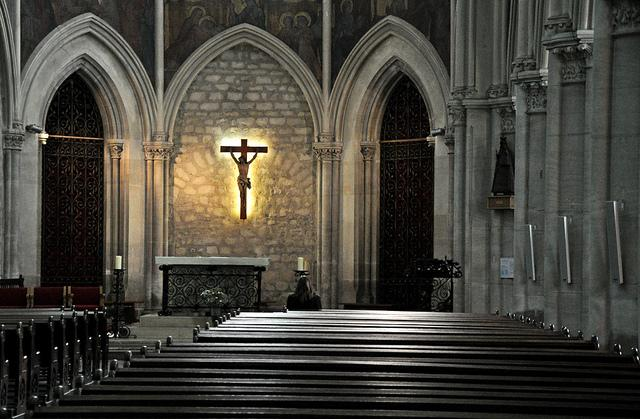What is she doing? Please explain your reasoning. praying. She's praying. 